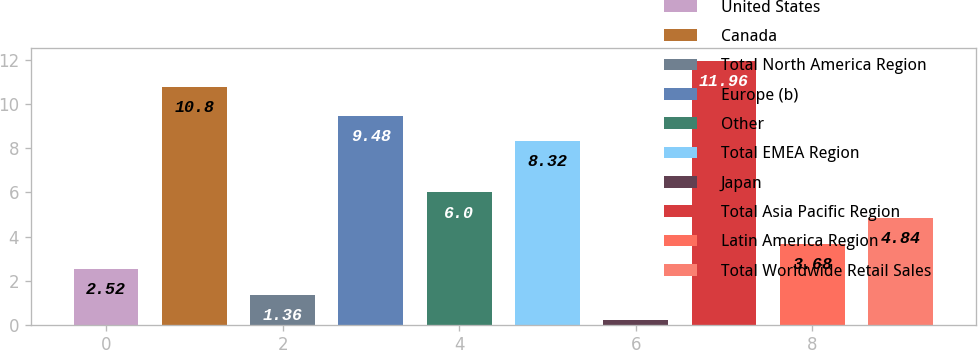Convert chart to OTSL. <chart><loc_0><loc_0><loc_500><loc_500><bar_chart><fcel>United States<fcel>Canada<fcel>Total North America Region<fcel>Europe (b)<fcel>Other<fcel>Total EMEA Region<fcel>Japan<fcel>Total Asia Pacific Region<fcel>Latin America Region<fcel>Total Worldwide Retail Sales<nl><fcel>2.52<fcel>10.8<fcel>1.36<fcel>9.48<fcel>6<fcel>8.32<fcel>0.2<fcel>11.96<fcel>3.68<fcel>4.84<nl></chart> 